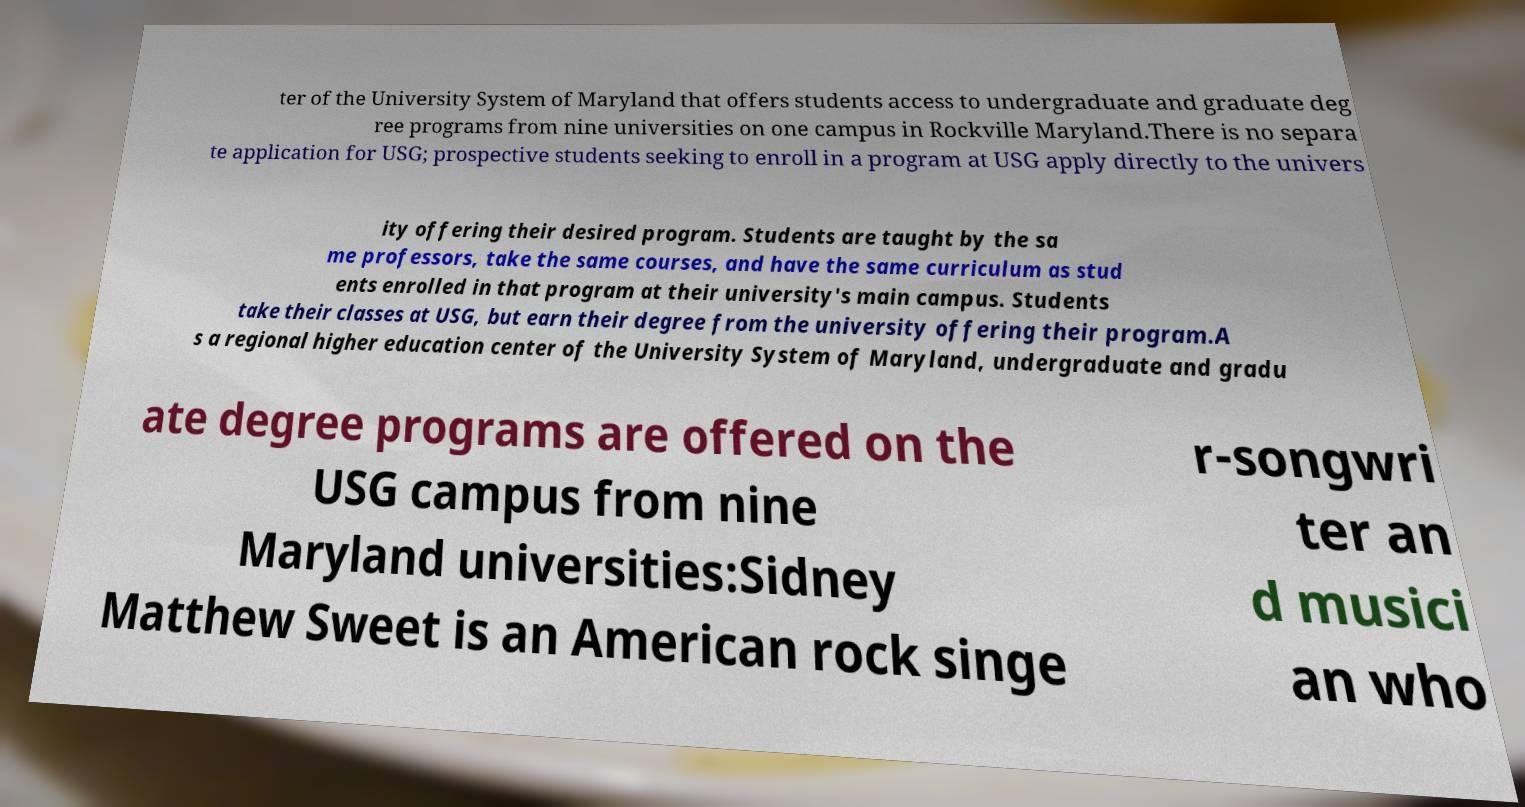Could you assist in decoding the text presented in this image and type it out clearly? ter of the University System of Maryland that offers students access to undergraduate and graduate deg ree programs from nine universities on one campus in Rockville Maryland.There is no separa te application for USG; prospective students seeking to enroll in a program at USG apply directly to the univers ity offering their desired program. Students are taught by the sa me professors, take the same courses, and have the same curriculum as stud ents enrolled in that program at their university's main campus. Students take their classes at USG, but earn their degree from the university offering their program.A s a regional higher education center of the University System of Maryland, undergraduate and gradu ate degree programs are offered on the USG campus from nine Maryland universities:Sidney Matthew Sweet is an American rock singe r-songwri ter an d musici an who 